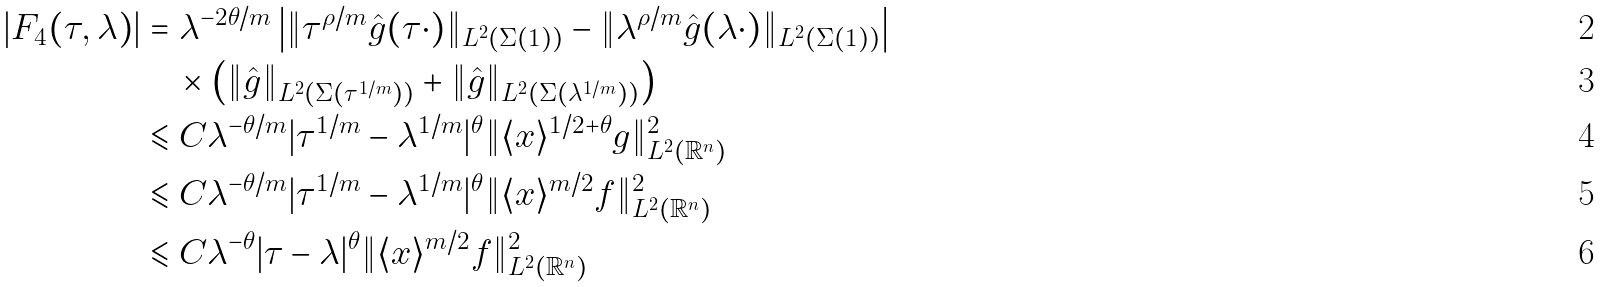Convert formula to latex. <formula><loc_0><loc_0><loc_500><loc_500>| { F _ { 4 } ( \tau , \lambda ) } | & = \lambda ^ { - 2 \theta / m } \left | \| \tau ^ { \rho / m } \hat { g } ( \tau \cdot ) \| _ { L ^ { 2 } ( \Sigma ( 1 ) ) } - \| \lambda ^ { \rho / m } \hat { g } ( \lambda \cdot ) \| _ { L ^ { 2 } ( \Sigma ( 1 ) ) } \right | \\ & \quad \times \left ( \| \hat { g } \| _ { L ^ { 2 } ( \Sigma ( \tau ^ { 1 / m } ) ) } + \| \hat { g } \| _ { L ^ { 2 } ( \Sigma ( \lambda ^ { 1 / m } ) ) } \right ) \\ & \leqslant C \lambda ^ { - \theta / m } | \tau ^ { 1 / m } - \lambda ^ { 1 / m } | ^ { \theta } \| \langle { x } \rangle ^ { 1 / 2 + \theta } g \| _ { L ^ { 2 } ( \mathbb { R } ^ { n } ) } ^ { 2 } \\ & \leqslant C \lambda ^ { - \theta / m } | \tau ^ { 1 / m } - \lambda ^ { 1 / m } | ^ { \theta } \| \langle { x } \rangle ^ { m / 2 } f \| _ { L ^ { 2 } ( \mathbb { R } ^ { n } ) } ^ { 2 } \\ & \leqslant C \lambda ^ { - \theta } | \tau - \lambda | ^ { \theta } \| \langle { x } \rangle ^ { m / 2 } f \| _ { L ^ { 2 } ( \mathbb { R } ^ { n } ) } ^ { 2 }</formula> 